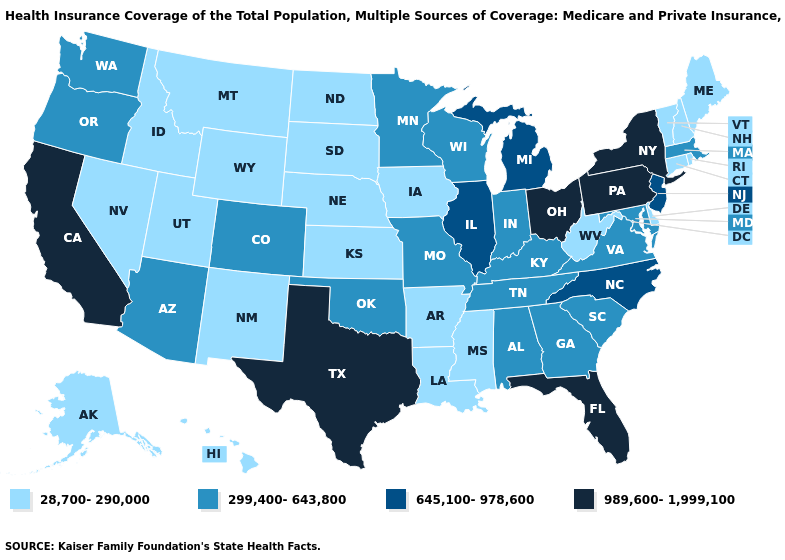Name the states that have a value in the range 28,700-290,000?
Write a very short answer. Alaska, Arkansas, Connecticut, Delaware, Hawaii, Idaho, Iowa, Kansas, Louisiana, Maine, Mississippi, Montana, Nebraska, Nevada, New Hampshire, New Mexico, North Dakota, Rhode Island, South Dakota, Utah, Vermont, West Virginia, Wyoming. Which states hav the highest value in the Northeast?
Give a very brief answer. New York, Pennsylvania. Name the states that have a value in the range 299,400-643,800?
Be succinct. Alabama, Arizona, Colorado, Georgia, Indiana, Kentucky, Maryland, Massachusetts, Minnesota, Missouri, Oklahoma, Oregon, South Carolina, Tennessee, Virginia, Washington, Wisconsin. How many symbols are there in the legend?
Keep it brief. 4. What is the value of New Mexico?
Concise answer only. 28,700-290,000. What is the highest value in the West ?
Keep it brief. 989,600-1,999,100. What is the value of Mississippi?
Concise answer only. 28,700-290,000. Does Missouri have a higher value than Nebraska?
Short answer required. Yes. Does Mississippi have the highest value in the USA?
Short answer required. No. What is the value of New Mexico?
Be succinct. 28,700-290,000. Does Florida have the same value as New Hampshire?
Quick response, please. No. What is the value of Kansas?
Be succinct. 28,700-290,000. What is the highest value in the USA?
Give a very brief answer. 989,600-1,999,100. Name the states that have a value in the range 28,700-290,000?
Concise answer only. Alaska, Arkansas, Connecticut, Delaware, Hawaii, Idaho, Iowa, Kansas, Louisiana, Maine, Mississippi, Montana, Nebraska, Nevada, New Hampshire, New Mexico, North Dakota, Rhode Island, South Dakota, Utah, Vermont, West Virginia, Wyoming. What is the highest value in the South ?
Short answer required. 989,600-1,999,100. 